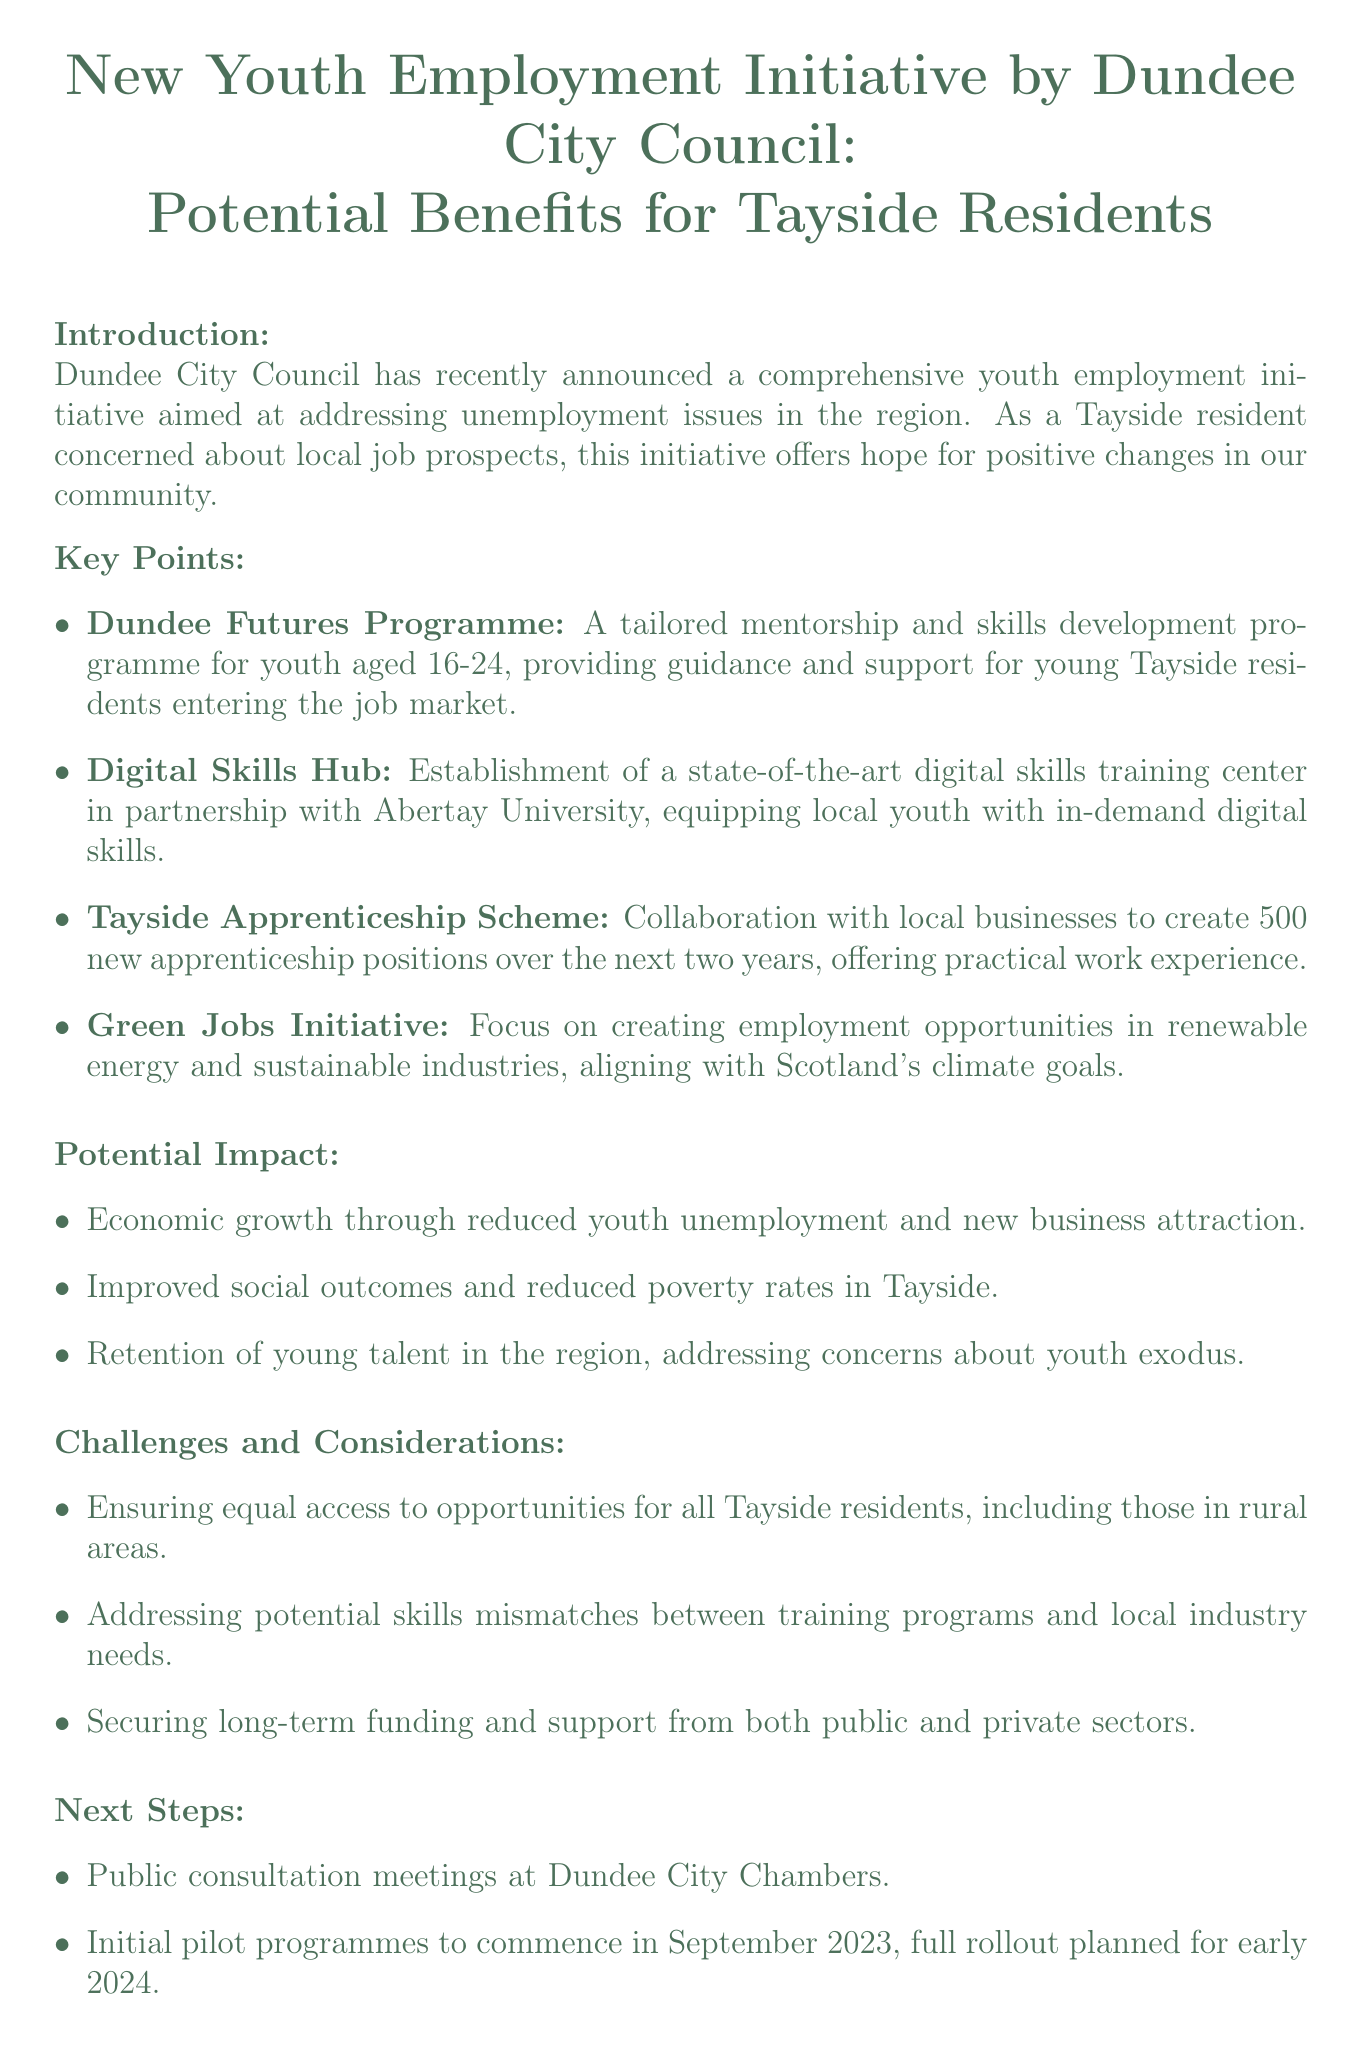What is the title of the memo? The title of the memo is explicitly stated at the beginning of the document.
Answer: New Youth Employment Initiative by Dundee City Council: Potential Benefits for Tayside Residents What age group does the Dundee Futures Programme target? The document specifies that the Dundee Futures Programme is aimed at youth aged 16-24.
Answer: 16-24 How many apprenticeship positions are planned to be created in the Tayside Apprenticeship Scheme? The memo outlines that the Tayside Apprenticeship Scheme aims to create 500 new apprenticeship positions.
Answer: 500 What is the focus of the Green Jobs Initiative? The document mentions that the Green Jobs Initiative focuses on creating employment opportunities in renewable energy and sustainable industries.
Answer: Renewable energy and sustainable industries When will the initial pilot programmes commence? The starting date for the initial pilot programmes is stated in the next steps section of the memo.
Answer: September 2023 What is one potential benefit of the initiative regarding community wellbeing? The memo identifies improved social outcomes as a potential benefit of the initiative.
Answer: Improved social outcomes What is a challenge mentioned in the document regarding access to opportunities? The document highlights ensuring equal access to opportunities for all Tayside residents as one of the challenges.
Answer: Equal access What type of meetings will Dundee City Council hold to gather feedback? The memo describes that public meetings will be held specifically for gathering resident feedback.
Answer: Public meetings 